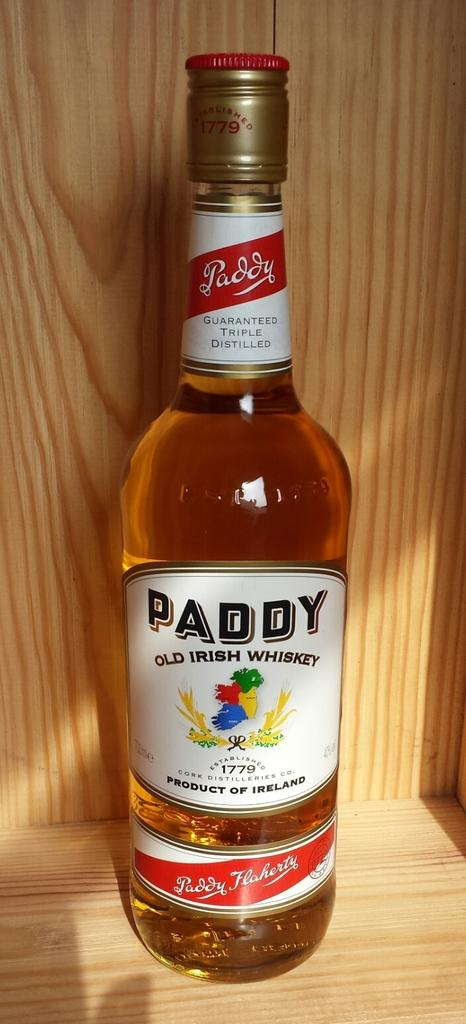<image>
Describe the image concisely. a bottle of paddy old irish whiskey from ireland 